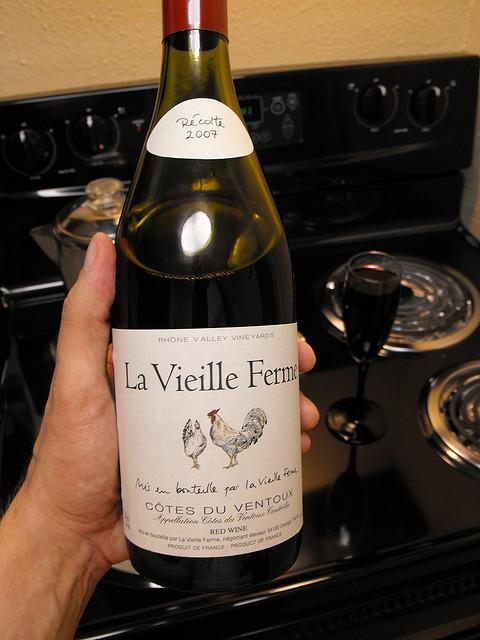What gift would this person enjoy assuming they like what they are holding? wine 